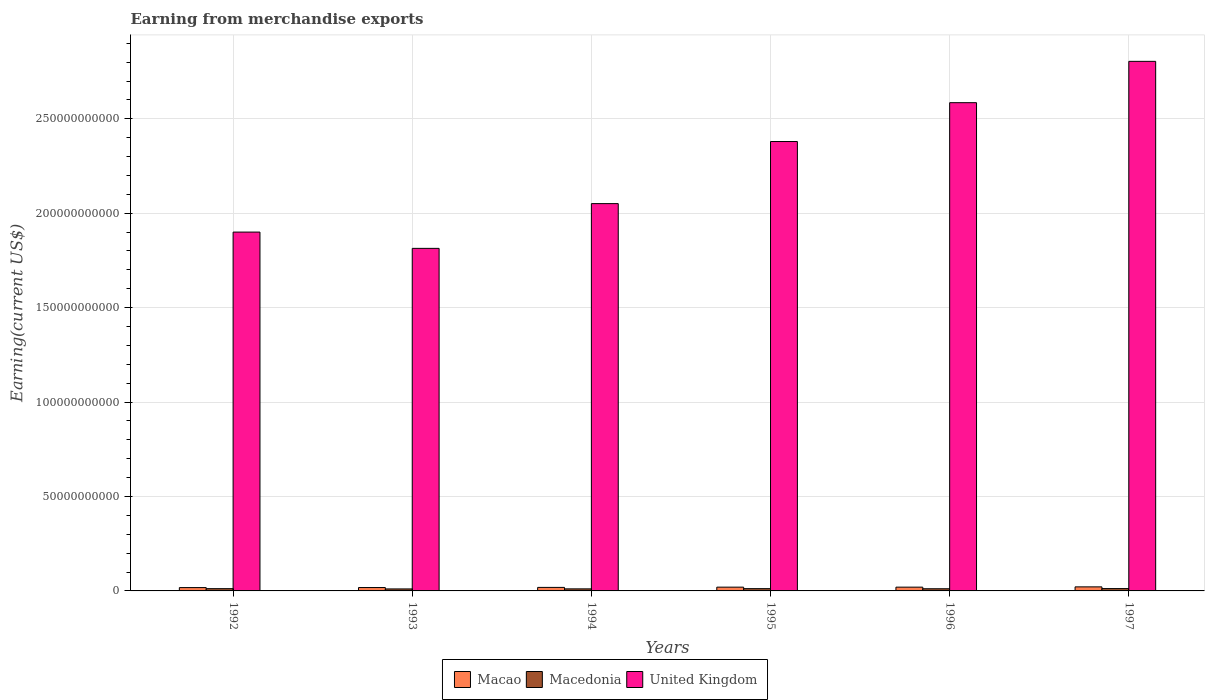How many different coloured bars are there?
Provide a short and direct response. 3. Are the number of bars on each tick of the X-axis equal?
Provide a short and direct response. Yes. In how many cases, is the number of bars for a given year not equal to the number of legend labels?
Provide a succinct answer. 0. What is the amount earned from merchandise exports in Macedonia in 1995?
Ensure brevity in your answer.  1.20e+09. Across all years, what is the maximum amount earned from merchandise exports in Macao?
Keep it short and to the point. 2.15e+09. Across all years, what is the minimum amount earned from merchandise exports in Macedonia?
Ensure brevity in your answer.  1.06e+09. What is the total amount earned from merchandise exports in Macao in the graph?
Provide a succinct answer. 1.16e+1. What is the difference between the amount earned from merchandise exports in Macao in 1993 and that in 1995?
Give a very brief answer. -2.10e+08. What is the difference between the amount earned from merchandise exports in United Kingdom in 1993 and the amount earned from merchandise exports in Macao in 1994?
Provide a succinct answer. 1.80e+11. What is the average amount earned from merchandise exports in Macao per year?
Provide a succinct answer. 1.93e+09. In the year 1992, what is the difference between the amount earned from merchandise exports in United Kingdom and amount earned from merchandise exports in Macedonia?
Offer a terse response. 1.89e+11. In how many years, is the amount earned from merchandise exports in United Kingdom greater than 110000000000 US$?
Offer a very short reply. 6. What is the ratio of the amount earned from merchandise exports in Macao in 1994 to that in 1996?
Keep it short and to the point. 0.93. Is the amount earned from merchandise exports in United Kingdom in 1992 less than that in 1994?
Give a very brief answer. Yes. What is the difference between the highest and the second highest amount earned from merchandise exports in United Kingdom?
Ensure brevity in your answer.  2.19e+1. What is the difference between the highest and the lowest amount earned from merchandise exports in United Kingdom?
Your answer should be very brief. 9.90e+1. In how many years, is the amount earned from merchandise exports in Macedonia greater than the average amount earned from merchandise exports in Macedonia taken over all years?
Make the answer very short. 3. What does the 1st bar from the right in 1992 represents?
Your answer should be very brief. United Kingdom. What is the difference between two consecutive major ticks on the Y-axis?
Offer a terse response. 5.00e+1. What is the title of the graph?
Ensure brevity in your answer.  Earning from merchandise exports. Does "Madagascar" appear as one of the legend labels in the graph?
Offer a terse response. No. What is the label or title of the X-axis?
Provide a succinct answer. Years. What is the label or title of the Y-axis?
Keep it short and to the point. Earning(current US$). What is the Earning(current US$) of Macao in 1992?
Offer a very short reply. 1.77e+09. What is the Earning(current US$) of Macedonia in 1992?
Make the answer very short. 1.20e+09. What is the Earning(current US$) in United Kingdom in 1992?
Give a very brief answer. 1.90e+11. What is the Earning(current US$) of Macao in 1993?
Your response must be concise. 1.79e+09. What is the Earning(current US$) in Macedonia in 1993?
Make the answer very short. 1.06e+09. What is the Earning(current US$) in United Kingdom in 1993?
Offer a terse response. 1.81e+11. What is the Earning(current US$) of Macao in 1994?
Offer a terse response. 1.87e+09. What is the Earning(current US$) in Macedonia in 1994?
Your response must be concise. 1.09e+09. What is the Earning(current US$) in United Kingdom in 1994?
Offer a very short reply. 2.05e+11. What is the Earning(current US$) in Macao in 1995?
Keep it short and to the point. 2.00e+09. What is the Earning(current US$) in Macedonia in 1995?
Your answer should be compact. 1.20e+09. What is the Earning(current US$) of United Kingdom in 1995?
Make the answer very short. 2.38e+11. What is the Earning(current US$) in Macao in 1996?
Offer a terse response. 2.00e+09. What is the Earning(current US$) of Macedonia in 1996?
Offer a terse response. 1.15e+09. What is the Earning(current US$) in United Kingdom in 1996?
Provide a succinct answer. 2.59e+11. What is the Earning(current US$) in Macao in 1997?
Offer a terse response. 2.15e+09. What is the Earning(current US$) in Macedonia in 1997?
Your response must be concise. 1.24e+09. What is the Earning(current US$) in United Kingdom in 1997?
Make the answer very short. 2.80e+11. Across all years, what is the maximum Earning(current US$) of Macao?
Your answer should be very brief. 2.15e+09. Across all years, what is the maximum Earning(current US$) in Macedonia?
Provide a succinct answer. 1.24e+09. Across all years, what is the maximum Earning(current US$) of United Kingdom?
Offer a terse response. 2.80e+11. Across all years, what is the minimum Earning(current US$) of Macao?
Your response must be concise. 1.77e+09. Across all years, what is the minimum Earning(current US$) in Macedonia?
Offer a very short reply. 1.06e+09. Across all years, what is the minimum Earning(current US$) of United Kingdom?
Offer a very short reply. 1.81e+11. What is the total Earning(current US$) of Macao in the graph?
Your answer should be very brief. 1.16e+1. What is the total Earning(current US$) of Macedonia in the graph?
Your answer should be very brief. 6.93e+09. What is the total Earning(current US$) of United Kingdom in the graph?
Ensure brevity in your answer.  1.35e+12. What is the difference between the Earning(current US$) in Macao in 1992 and that in 1993?
Provide a succinct answer. -2.10e+07. What is the difference between the Earning(current US$) in Macedonia in 1992 and that in 1993?
Keep it short and to the point. 1.44e+08. What is the difference between the Earning(current US$) of United Kingdom in 1992 and that in 1993?
Keep it short and to the point. 8.62e+09. What is the difference between the Earning(current US$) of Macao in 1992 and that in 1994?
Your answer should be compact. -1.00e+08. What is the difference between the Earning(current US$) of Macedonia in 1992 and that in 1994?
Keep it short and to the point. 1.13e+08. What is the difference between the Earning(current US$) in United Kingdom in 1992 and that in 1994?
Provide a short and direct response. -1.51e+1. What is the difference between the Earning(current US$) in Macao in 1992 and that in 1995?
Offer a terse response. -2.31e+08. What is the difference between the Earning(current US$) of Macedonia in 1992 and that in 1995?
Give a very brief answer. -5.00e+06. What is the difference between the Earning(current US$) of United Kingdom in 1992 and that in 1995?
Provide a succinct answer. -4.80e+1. What is the difference between the Earning(current US$) of Macao in 1992 and that in 1996?
Provide a succinct answer. -2.30e+08. What is the difference between the Earning(current US$) of Macedonia in 1992 and that in 1996?
Offer a terse response. 5.20e+07. What is the difference between the Earning(current US$) of United Kingdom in 1992 and that in 1996?
Offer a very short reply. -6.85e+1. What is the difference between the Earning(current US$) in Macao in 1992 and that in 1997?
Offer a terse response. -3.82e+08. What is the difference between the Earning(current US$) in Macedonia in 1992 and that in 1997?
Give a very brief answer. -3.80e+07. What is the difference between the Earning(current US$) of United Kingdom in 1992 and that in 1997?
Make the answer very short. -9.04e+1. What is the difference between the Earning(current US$) in Macao in 1993 and that in 1994?
Your answer should be compact. -7.90e+07. What is the difference between the Earning(current US$) in Macedonia in 1993 and that in 1994?
Offer a very short reply. -3.10e+07. What is the difference between the Earning(current US$) in United Kingdom in 1993 and that in 1994?
Give a very brief answer. -2.37e+1. What is the difference between the Earning(current US$) in Macao in 1993 and that in 1995?
Ensure brevity in your answer.  -2.10e+08. What is the difference between the Earning(current US$) of Macedonia in 1993 and that in 1995?
Your answer should be very brief. -1.49e+08. What is the difference between the Earning(current US$) of United Kingdom in 1993 and that in 1995?
Offer a terse response. -5.66e+1. What is the difference between the Earning(current US$) of Macao in 1993 and that in 1996?
Make the answer very short. -2.09e+08. What is the difference between the Earning(current US$) of Macedonia in 1993 and that in 1996?
Your answer should be very brief. -9.20e+07. What is the difference between the Earning(current US$) in United Kingdom in 1993 and that in 1996?
Your response must be concise. -7.71e+1. What is the difference between the Earning(current US$) in Macao in 1993 and that in 1997?
Ensure brevity in your answer.  -3.61e+08. What is the difference between the Earning(current US$) in Macedonia in 1993 and that in 1997?
Provide a short and direct response. -1.82e+08. What is the difference between the Earning(current US$) of United Kingdom in 1993 and that in 1997?
Keep it short and to the point. -9.90e+1. What is the difference between the Earning(current US$) of Macao in 1994 and that in 1995?
Offer a very short reply. -1.31e+08. What is the difference between the Earning(current US$) in Macedonia in 1994 and that in 1995?
Give a very brief answer. -1.18e+08. What is the difference between the Earning(current US$) of United Kingdom in 1994 and that in 1995?
Provide a succinct answer. -3.29e+1. What is the difference between the Earning(current US$) of Macao in 1994 and that in 1996?
Ensure brevity in your answer.  -1.30e+08. What is the difference between the Earning(current US$) of Macedonia in 1994 and that in 1996?
Give a very brief answer. -6.10e+07. What is the difference between the Earning(current US$) of United Kingdom in 1994 and that in 1996?
Your answer should be very brief. -5.34e+1. What is the difference between the Earning(current US$) of Macao in 1994 and that in 1997?
Ensure brevity in your answer.  -2.82e+08. What is the difference between the Earning(current US$) of Macedonia in 1994 and that in 1997?
Ensure brevity in your answer.  -1.51e+08. What is the difference between the Earning(current US$) of United Kingdom in 1994 and that in 1997?
Make the answer very short. -7.53e+1. What is the difference between the Earning(current US$) in Macedonia in 1995 and that in 1996?
Offer a terse response. 5.70e+07. What is the difference between the Earning(current US$) of United Kingdom in 1995 and that in 1996?
Offer a terse response. -2.06e+1. What is the difference between the Earning(current US$) of Macao in 1995 and that in 1997?
Ensure brevity in your answer.  -1.51e+08. What is the difference between the Earning(current US$) in Macedonia in 1995 and that in 1997?
Offer a terse response. -3.30e+07. What is the difference between the Earning(current US$) in United Kingdom in 1995 and that in 1997?
Provide a short and direct response. -4.25e+1. What is the difference between the Earning(current US$) in Macao in 1996 and that in 1997?
Make the answer very short. -1.52e+08. What is the difference between the Earning(current US$) in Macedonia in 1996 and that in 1997?
Give a very brief answer. -9.00e+07. What is the difference between the Earning(current US$) in United Kingdom in 1996 and that in 1997?
Provide a short and direct response. -2.19e+1. What is the difference between the Earning(current US$) of Macao in 1992 and the Earning(current US$) of Macedonia in 1993?
Your answer should be very brief. 7.11e+08. What is the difference between the Earning(current US$) of Macao in 1992 and the Earning(current US$) of United Kingdom in 1993?
Ensure brevity in your answer.  -1.80e+11. What is the difference between the Earning(current US$) in Macedonia in 1992 and the Earning(current US$) in United Kingdom in 1993?
Keep it short and to the point. -1.80e+11. What is the difference between the Earning(current US$) of Macao in 1992 and the Earning(current US$) of Macedonia in 1994?
Keep it short and to the point. 6.80e+08. What is the difference between the Earning(current US$) in Macao in 1992 and the Earning(current US$) in United Kingdom in 1994?
Make the answer very short. -2.03e+11. What is the difference between the Earning(current US$) of Macedonia in 1992 and the Earning(current US$) of United Kingdom in 1994?
Keep it short and to the point. -2.04e+11. What is the difference between the Earning(current US$) in Macao in 1992 and the Earning(current US$) in Macedonia in 1995?
Your answer should be compact. 5.62e+08. What is the difference between the Earning(current US$) in Macao in 1992 and the Earning(current US$) in United Kingdom in 1995?
Provide a short and direct response. -2.36e+11. What is the difference between the Earning(current US$) in Macedonia in 1992 and the Earning(current US$) in United Kingdom in 1995?
Your answer should be very brief. -2.37e+11. What is the difference between the Earning(current US$) in Macao in 1992 and the Earning(current US$) in Macedonia in 1996?
Your response must be concise. 6.19e+08. What is the difference between the Earning(current US$) in Macao in 1992 and the Earning(current US$) in United Kingdom in 1996?
Give a very brief answer. -2.57e+11. What is the difference between the Earning(current US$) of Macedonia in 1992 and the Earning(current US$) of United Kingdom in 1996?
Your answer should be compact. -2.57e+11. What is the difference between the Earning(current US$) of Macao in 1992 and the Earning(current US$) of Macedonia in 1997?
Offer a terse response. 5.29e+08. What is the difference between the Earning(current US$) in Macao in 1992 and the Earning(current US$) in United Kingdom in 1997?
Your answer should be very brief. -2.79e+11. What is the difference between the Earning(current US$) in Macedonia in 1992 and the Earning(current US$) in United Kingdom in 1997?
Make the answer very short. -2.79e+11. What is the difference between the Earning(current US$) of Macao in 1993 and the Earning(current US$) of Macedonia in 1994?
Your response must be concise. 7.01e+08. What is the difference between the Earning(current US$) in Macao in 1993 and the Earning(current US$) in United Kingdom in 1994?
Your response must be concise. -2.03e+11. What is the difference between the Earning(current US$) of Macedonia in 1993 and the Earning(current US$) of United Kingdom in 1994?
Give a very brief answer. -2.04e+11. What is the difference between the Earning(current US$) in Macao in 1993 and the Earning(current US$) in Macedonia in 1995?
Your response must be concise. 5.83e+08. What is the difference between the Earning(current US$) in Macao in 1993 and the Earning(current US$) in United Kingdom in 1995?
Your answer should be compact. -2.36e+11. What is the difference between the Earning(current US$) in Macedonia in 1993 and the Earning(current US$) in United Kingdom in 1995?
Give a very brief answer. -2.37e+11. What is the difference between the Earning(current US$) of Macao in 1993 and the Earning(current US$) of Macedonia in 1996?
Make the answer very short. 6.40e+08. What is the difference between the Earning(current US$) in Macao in 1993 and the Earning(current US$) in United Kingdom in 1996?
Your answer should be very brief. -2.57e+11. What is the difference between the Earning(current US$) of Macedonia in 1993 and the Earning(current US$) of United Kingdom in 1996?
Offer a terse response. -2.57e+11. What is the difference between the Earning(current US$) of Macao in 1993 and the Earning(current US$) of Macedonia in 1997?
Offer a terse response. 5.50e+08. What is the difference between the Earning(current US$) of Macao in 1993 and the Earning(current US$) of United Kingdom in 1997?
Offer a terse response. -2.79e+11. What is the difference between the Earning(current US$) in Macedonia in 1993 and the Earning(current US$) in United Kingdom in 1997?
Ensure brevity in your answer.  -2.79e+11. What is the difference between the Earning(current US$) of Macao in 1994 and the Earning(current US$) of Macedonia in 1995?
Your response must be concise. 6.62e+08. What is the difference between the Earning(current US$) of Macao in 1994 and the Earning(current US$) of United Kingdom in 1995?
Make the answer very short. -2.36e+11. What is the difference between the Earning(current US$) of Macedonia in 1994 and the Earning(current US$) of United Kingdom in 1995?
Provide a succinct answer. -2.37e+11. What is the difference between the Earning(current US$) in Macao in 1994 and the Earning(current US$) in Macedonia in 1996?
Offer a very short reply. 7.19e+08. What is the difference between the Earning(current US$) of Macao in 1994 and the Earning(current US$) of United Kingdom in 1996?
Offer a terse response. -2.57e+11. What is the difference between the Earning(current US$) of Macedonia in 1994 and the Earning(current US$) of United Kingdom in 1996?
Make the answer very short. -2.57e+11. What is the difference between the Earning(current US$) in Macao in 1994 and the Earning(current US$) in Macedonia in 1997?
Make the answer very short. 6.29e+08. What is the difference between the Earning(current US$) in Macao in 1994 and the Earning(current US$) in United Kingdom in 1997?
Make the answer very short. -2.79e+11. What is the difference between the Earning(current US$) in Macedonia in 1994 and the Earning(current US$) in United Kingdom in 1997?
Make the answer very short. -2.79e+11. What is the difference between the Earning(current US$) in Macao in 1995 and the Earning(current US$) in Macedonia in 1996?
Your response must be concise. 8.50e+08. What is the difference between the Earning(current US$) in Macao in 1995 and the Earning(current US$) in United Kingdom in 1996?
Provide a short and direct response. -2.57e+11. What is the difference between the Earning(current US$) of Macedonia in 1995 and the Earning(current US$) of United Kingdom in 1996?
Your answer should be compact. -2.57e+11. What is the difference between the Earning(current US$) in Macao in 1995 and the Earning(current US$) in Macedonia in 1997?
Offer a very short reply. 7.60e+08. What is the difference between the Earning(current US$) of Macao in 1995 and the Earning(current US$) of United Kingdom in 1997?
Offer a terse response. -2.78e+11. What is the difference between the Earning(current US$) of Macedonia in 1995 and the Earning(current US$) of United Kingdom in 1997?
Ensure brevity in your answer.  -2.79e+11. What is the difference between the Earning(current US$) in Macao in 1996 and the Earning(current US$) in Macedonia in 1997?
Make the answer very short. 7.59e+08. What is the difference between the Earning(current US$) in Macao in 1996 and the Earning(current US$) in United Kingdom in 1997?
Keep it short and to the point. -2.78e+11. What is the difference between the Earning(current US$) of Macedonia in 1996 and the Earning(current US$) of United Kingdom in 1997?
Ensure brevity in your answer.  -2.79e+11. What is the average Earning(current US$) in Macao per year?
Keep it short and to the point. 1.93e+09. What is the average Earning(current US$) in Macedonia per year?
Ensure brevity in your answer.  1.15e+09. What is the average Earning(current US$) of United Kingdom per year?
Ensure brevity in your answer.  2.26e+11. In the year 1992, what is the difference between the Earning(current US$) in Macao and Earning(current US$) in Macedonia?
Your answer should be very brief. 5.67e+08. In the year 1992, what is the difference between the Earning(current US$) in Macao and Earning(current US$) in United Kingdom?
Offer a terse response. -1.88e+11. In the year 1992, what is the difference between the Earning(current US$) of Macedonia and Earning(current US$) of United Kingdom?
Provide a succinct answer. -1.89e+11. In the year 1993, what is the difference between the Earning(current US$) in Macao and Earning(current US$) in Macedonia?
Offer a terse response. 7.32e+08. In the year 1993, what is the difference between the Earning(current US$) in Macao and Earning(current US$) in United Kingdom?
Your answer should be compact. -1.80e+11. In the year 1993, what is the difference between the Earning(current US$) in Macedonia and Earning(current US$) in United Kingdom?
Make the answer very short. -1.80e+11. In the year 1994, what is the difference between the Earning(current US$) in Macao and Earning(current US$) in Macedonia?
Your answer should be very brief. 7.80e+08. In the year 1994, what is the difference between the Earning(current US$) of Macao and Earning(current US$) of United Kingdom?
Provide a succinct answer. -2.03e+11. In the year 1994, what is the difference between the Earning(current US$) of Macedonia and Earning(current US$) of United Kingdom?
Keep it short and to the point. -2.04e+11. In the year 1995, what is the difference between the Earning(current US$) of Macao and Earning(current US$) of Macedonia?
Give a very brief answer. 7.93e+08. In the year 1995, what is the difference between the Earning(current US$) in Macao and Earning(current US$) in United Kingdom?
Provide a succinct answer. -2.36e+11. In the year 1995, what is the difference between the Earning(current US$) in Macedonia and Earning(current US$) in United Kingdom?
Give a very brief answer. -2.37e+11. In the year 1996, what is the difference between the Earning(current US$) of Macao and Earning(current US$) of Macedonia?
Ensure brevity in your answer.  8.49e+08. In the year 1996, what is the difference between the Earning(current US$) of Macao and Earning(current US$) of United Kingdom?
Your answer should be compact. -2.57e+11. In the year 1996, what is the difference between the Earning(current US$) of Macedonia and Earning(current US$) of United Kingdom?
Offer a terse response. -2.57e+11. In the year 1997, what is the difference between the Earning(current US$) of Macao and Earning(current US$) of Macedonia?
Provide a succinct answer. 9.11e+08. In the year 1997, what is the difference between the Earning(current US$) of Macao and Earning(current US$) of United Kingdom?
Your answer should be very brief. -2.78e+11. In the year 1997, what is the difference between the Earning(current US$) of Macedonia and Earning(current US$) of United Kingdom?
Provide a succinct answer. -2.79e+11. What is the ratio of the Earning(current US$) in Macao in 1992 to that in 1993?
Give a very brief answer. 0.99. What is the ratio of the Earning(current US$) in Macedonia in 1992 to that in 1993?
Provide a short and direct response. 1.14. What is the ratio of the Earning(current US$) in United Kingdom in 1992 to that in 1993?
Make the answer very short. 1.05. What is the ratio of the Earning(current US$) in Macao in 1992 to that in 1994?
Provide a short and direct response. 0.95. What is the ratio of the Earning(current US$) in Macedonia in 1992 to that in 1994?
Provide a short and direct response. 1.1. What is the ratio of the Earning(current US$) in United Kingdom in 1992 to that in 1994?
Your answer should be very brief. 0.93. What is the ratio of the Earning(current US$) in Macao in 1992 to that in 1995?
Give a very brief answer. 0.88. What is the ratio of the Earning(current US$) in United Kingdom in 1992 to that in 1995?
Give a very brief answer. 0.8. What is the ratio of the Earning(current US$) in Macao in 1992 to that in 1996?
Give a very brief answer. 0.88. What is the ratio of the Earning(current US$) in Macedonia in 1992 to that in 1996?
Keep it short and to the point. 1.05. What is the ratio of the Earning(current US$) in United Kingdom in 1992 to that in 1996?
Provide a short and direct response. 0.73. What is the ratio of the Earning(current US$) of Macao in 1992 to that in 1997?
Keep it short and to the point. 0.82. What is the ratio of the Earning(current US$) of Macedonia in 1992 to that in 1997?
Offer a terse response. 0.97. What is the ratio of the Earning(current US$) of United Kingdom in 1992 to that in 1997?
Offer a terse response. 0.68. What is the ratio of the Earning(current US$) in Macao in 1993 to that in 1994?
Give a very brief answer. 0.96. What is the ratio of the Earning(current US$) in Macedonia in 1993 to that in 1994?
Keep it short and to the point. 0.97. What is the ratio of the Earning(current US$) in United Kingdom in 1993 to that in 1994?
Offer a terse response. 0.88. What is the ratio of the Earning(current US$) in Macao in 1993 to that in 1995?
Your answer should be compact. 0.89. What is the ratio of the Earning(current US$) of Macedonia in 1993 to that in 1995?
Keep it short and to the point. 0.88. What is the ratio of the Earning(current US$) of United Kingdom in 1993 to that in 1995?
Your response must be concise. 0.76. What is the ratio of the Earning(current US$) of Macao in 1993 to that in 1996?
Offer a terse response. 0.9. What is the ratio of the Earning(current US$) of Macedonia in 1993 to that in 1996?
Your response must be concise. 0.92. What is the ratio of the Earning(current US$) in United Kingdom in 1993 to that in 1996?
Give a very brief answer. 0.7. What is the ratio of the Earning(current US$) in Macao in 1993 to that in 1997?
Give a very brief answer. 0.83. What is the ratio of the Earning(current US$) of Macedonia in 1993 to that in 1997?
Your answer should be compact. 0.85. What is the ratio of the Earning(current US$) in United Kingdom in 1993 to that in 1997?
Provide a succinct answer. 0.65. What is the ratio of the Earning(current US$) in Macao in 1994 to that in 1995?
Give a very brief answer. 0.93. What is the ratio of the Earning(current US$) in Macedonia in 1994 to that in 1995?
Make the answer very short. 0.9. What is the ratio of the Earning(current US$) of United Kingdom in 1994 to that in 1995?
Give a very brief answer. 0.86. What is the ratio of the Earning(current US$) of Macao in 1994 to that in 1996?
Give a very brief answer. 0.93. What is the ratio of the Earning(current US$) of Macedonia in 1994 to that in 1996?
Offer a terse response. 0.95. What is the ratio of the Earning(current US$) in United Kingdom in 1994 to that in 1996?
Give a very brief answer. 0.79. What is the ratio of the Earning(current US$) in Macao in 1994 to that in 1997?
Your answer should be compact. 0.87. What is the ratio of the Earning(current US$) of Macedonia in 1994 to that in 1997?
Offer a very short reply. 0.88. What is the ratio of the Earning(current US$) of United Kingdom in 1994 to that in 1997?
Provide a succinct answer. 0.73. What is the ratio of the Earning(current US$) in Macao in 1995 to that in 1996?
Make the answer very short. 1. What is the ratio of the Earning(current US$) in Macedonia in 1995 to that in 1996?
Give a very brief answer. 1.05. What is the ratio of the Earning(current US$) in United Kingdom in 1995 to that in 1996?
Your answer should be very brief. 0.92. What is the ratio of the Earning(current US$) of Macao in 1995 to that in 1997?
Your answer should be compact. 0.93. What is the ratio of the Earning(current US$) of Macedonia in 1995 to that in 1997?
Make the answer very short. 0.97. What is the ratio of the Earning(current US$) of United Kingdom in 1995 to that in 1997?
Your answer should be compact. 0.85. What is the ratio of the Earning(current US$) in Macao in 1996 to that in 1997?
Offer a very short reply. 0.93. What is the ratio of the Earning(current US$) of Macedonia in 1996 to that in 1997?
Make the answer very short. 0.93. What is the ratio of the Earning(current US$) in United Kingdom in 1996 to that in 1997?
Offer a terse response. 0.92. What is the difference between the highest and the second highest Earning(current US$) in Macao?
Keep it short and to the point. 1.51e+08. What is the difference between the highest and the second highest Earning(current US$) in Macedonia?
Your answer should be very brief. 3.30e+07. What is the difference between the highest and the second highest Earning(current US$) in United Kingdom?
Provide a succinct answer. 2.19e+1. What is the difference between the highest and the lowest Earning(current US$) of Macao?
Offer a terse response. 3.82e+08. What is the difference between the highest and the lowest Earning(current US$) in Macedonia?
Provide a succinct answer. 1.82e+08. What is the difference between the highest and the lowest Earning(current US$) in United Kingdom?
Provide a short and direct response. 9.90e+1. 